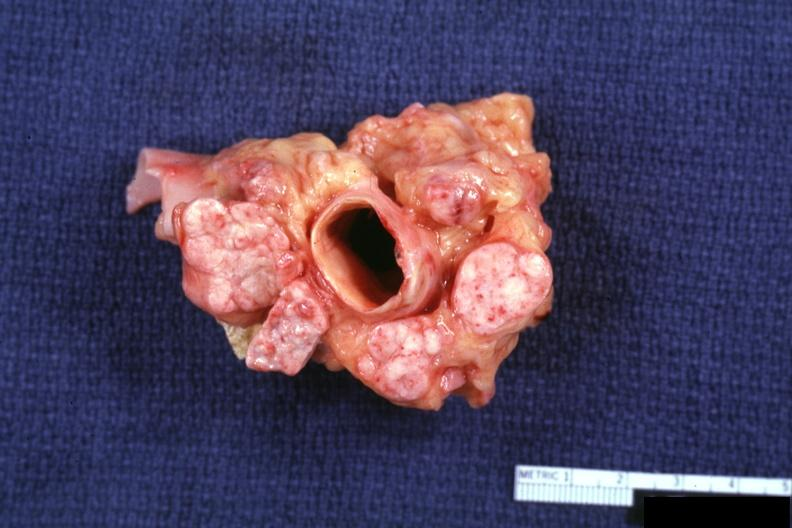s lymph node present?
Answer the question using a single word or phrase. Yes 